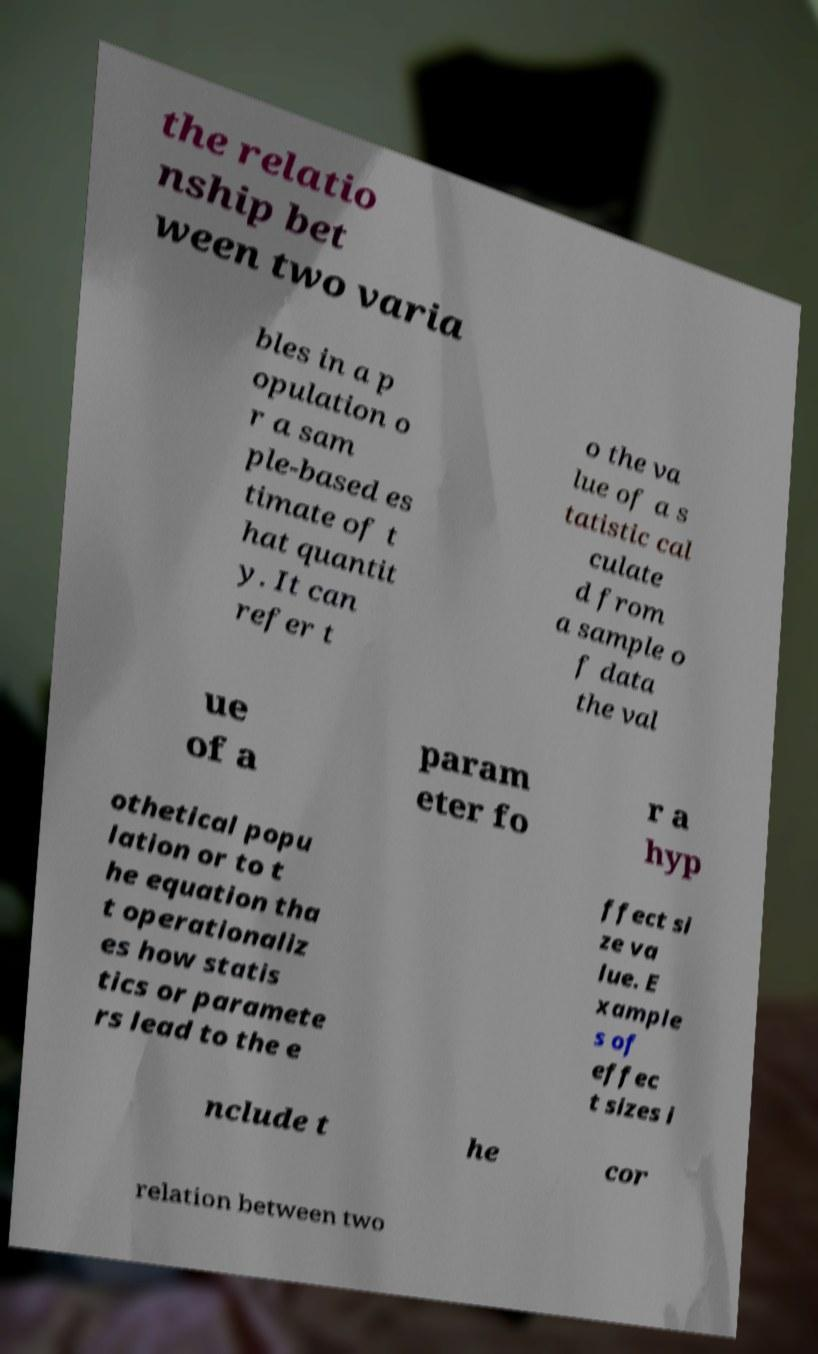Can you accurately transcribe the text from the provided image for me? the relatio nship bet ween two varia bles in a p opulation o r a sam ple-based es timate of t hat quantit y. It can refer t o the va lue of a s tatistic cal culate d from a sample o f data the val ue of a param eter fo r a hyp othetical popu lation or to t he equation tha t operationaliz es how statis tics or paramete rs lead to the e ffect si ze va lue. E xample s of effec t sizes i nclude t he cor relation between two 